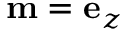Convert formula to latex. <formula><loc_0><loc_0><loc_500><loc_500>m = e _ { z }</formula> 